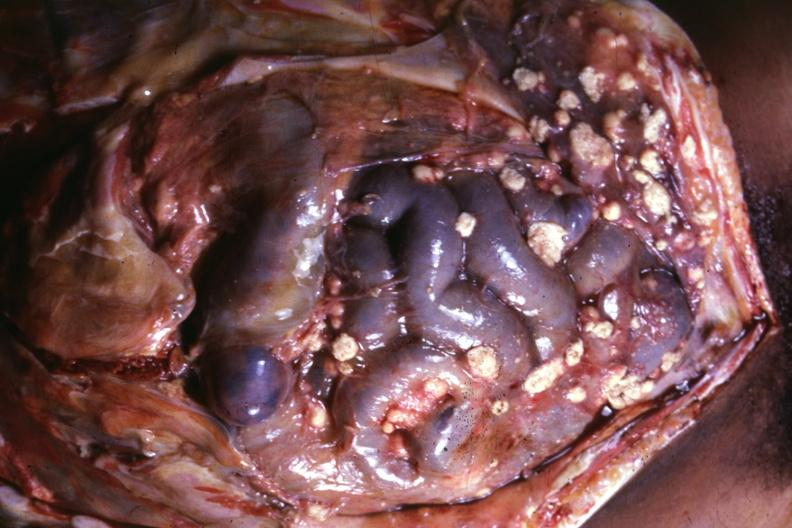s carcinomatosis present?
Answer the question using a single word or phrase. Yes 